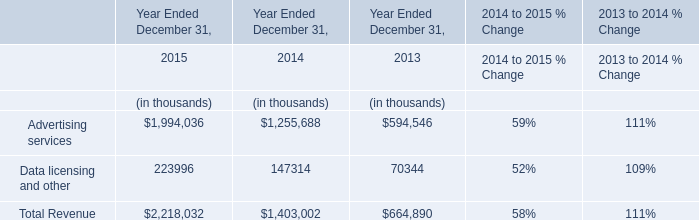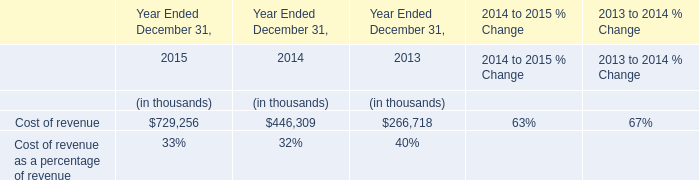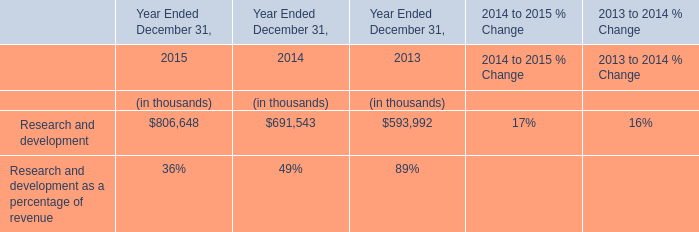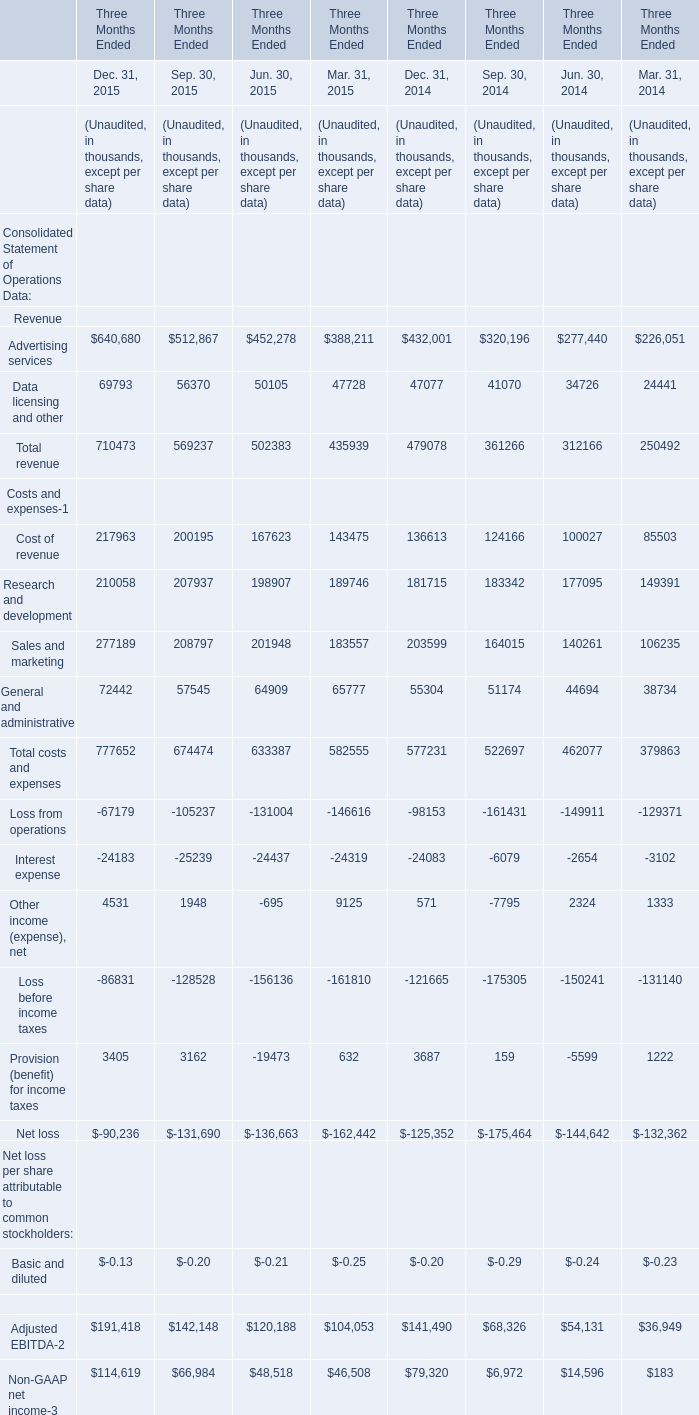What is the sum of the Research and development in the years where Cost of revenue for Sep. 30 greater than 200000? (in thousand) 
Computations: (((210058 + 207937) + 198907) + 189746)
Answer: 806648.0. 